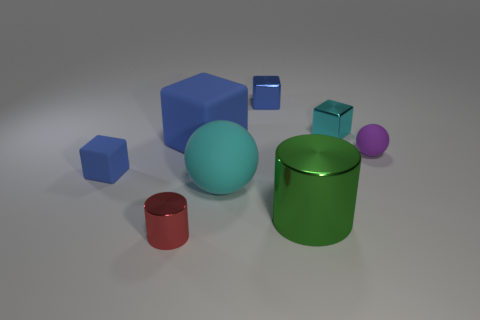There is a tiny blue object that is the same material as the small purple ball; what is its shape?
Your response must be concise. Cube. Does the big cyan object have the same shape as the small matte thing left of the red thing?
Offer a terse response. No. What is the material of the ball in front of the tiny rubber object left of the big blue rubber thing?
Provide a succinct answer. Rubber. Are there an equal number of tiny purple rubber things on the left side of the purple ball and red balls?
Give a very brief answer. Yes. Is there anything else that has the same material as the large block?
Your answer should be very brief. Yes. There is a ball that is on the right side of the cyan sphere; is it the same color as the small shiny object that is in front of the big green cylinder?
Offer a terse response. No. How many small things are behind the large green metal thing and in front of the tiny purple thing?
Ensure brevity in your answer.  1. What number of other objects are the same shape as the small blue metallic object?
Offer a very short reply. 3. Are there more small red cylinders behind the green thing than rubber objects?
Give a very brief answer. No. There is a large rubber object that is behind the small matte block; what color is it?
Offer a terse response. Blue. 